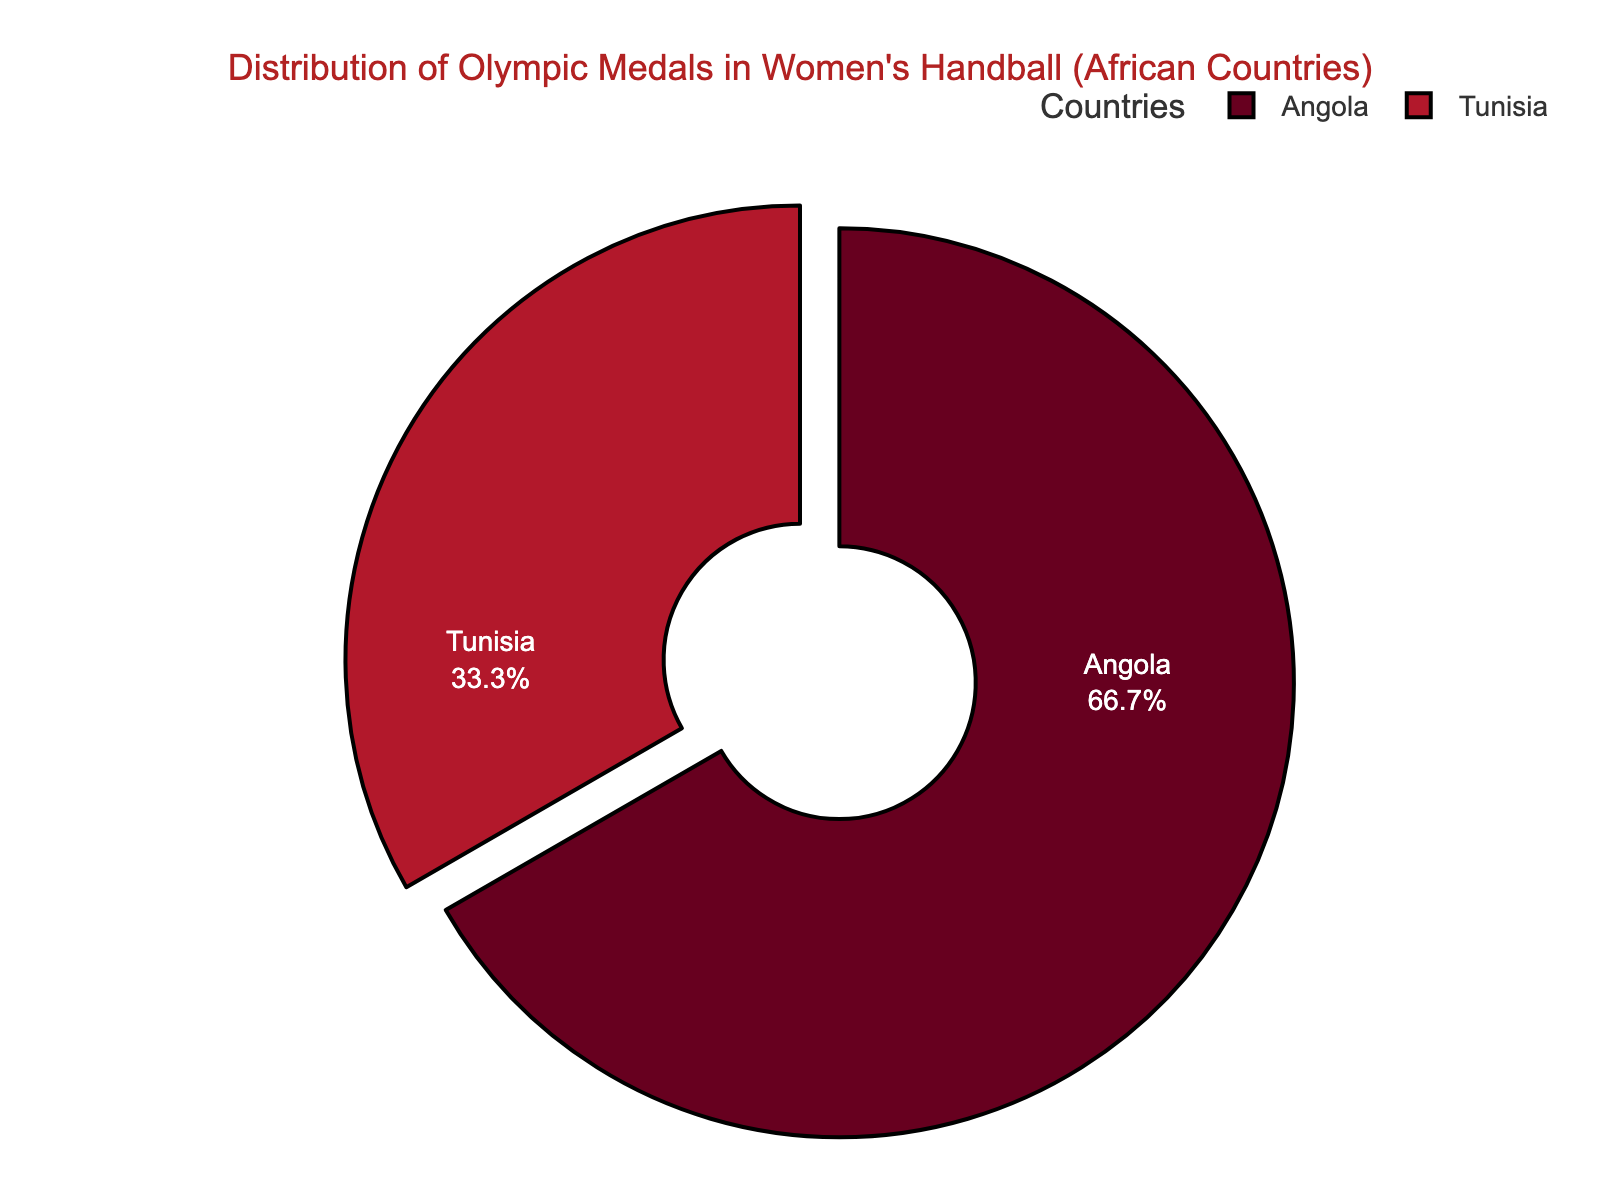What percentage of medals won by African countries in women's handball at the Olympics does Tunisia hold? In the pie chart, you can see that Tunisia's part of the circle represents a certain percentage of the total medals won by African countries. Since Tunisia has won 1 medal, we calculate this percentage by dividing 1 by the total number of medals won by African countries (Angola and Tunisia combined, which is 2+1=3) and then multiplying the result by 100. (1/3) * 100 = 33.33%
Answer: 33.33% Does Angola have more medals than Tunisia? In the pie chart, we can directly compare the sizes of the slices for Angola and Tunisia. Angola's slice is larger than Tunisia's slice. Angola has 2 medals while Tunisia has 1 medal, so Angola has more medals.
Answer: Yes How many more medals does Angola have compared to Tunisia? Look at the pie chart to see the medal counts for both Angola and Tunisia. Angola has 2 medals and Tunisia has 1. To find out how many more medals Angola has, subtract the number of medals Tunisia has from Angola's, which is 2 - 1 = 1.
Answer: 1 What fraction of the medals won by the African countries does Angola hold? Angola's slice of the pie chart represents its share of the total medals won by African countries. To find this fraction, divide the number of medals won by Angola (2) by the total number of medals won by African countries (3). This fraction is 2/3.
Answer: 2/3 Which African country has more medals, Angola or Tunisia? Look at the pie chart to compare the sizes of the slices. The slice for Angola is larger than the slice for Tunisia, indicating that Angola has more medals.
Answer: Angola What is the ratio of medals won by Angola to those won by Tunisia? From the pie chart, we can count the medals for both countries. Angola has 2 medals and Tunisia has 1 medal. The ratio of Angola's medals to Tunisia's medals is 2:1.
Answer: 2:1 How does the percentage of medals won by Tunisia compare to the percentage won by Angola? From the pie chart, we see that Angola's slice is larger. Angola has 2 medals out of 3, making (2/3) * 100 = 66.67%, and Tunisia has 1 medal out of 3, making (1/3) * 100 = 33.33%. Tunisia has a smaller percentage of medals.
Answer: Tunisia has a smaller percentage By how much does the percentage of medals won by Angola exceed that of Tunisia? The pie chart provides the percentages of medals. Angola's percentage is 66.67% while Tunisia’s is 33.33%. To find the difference, subtract Tunisia's percentage from Angola’s, which is 66.67% - 33.33% = 33.34%.
Answer: 33.34% 